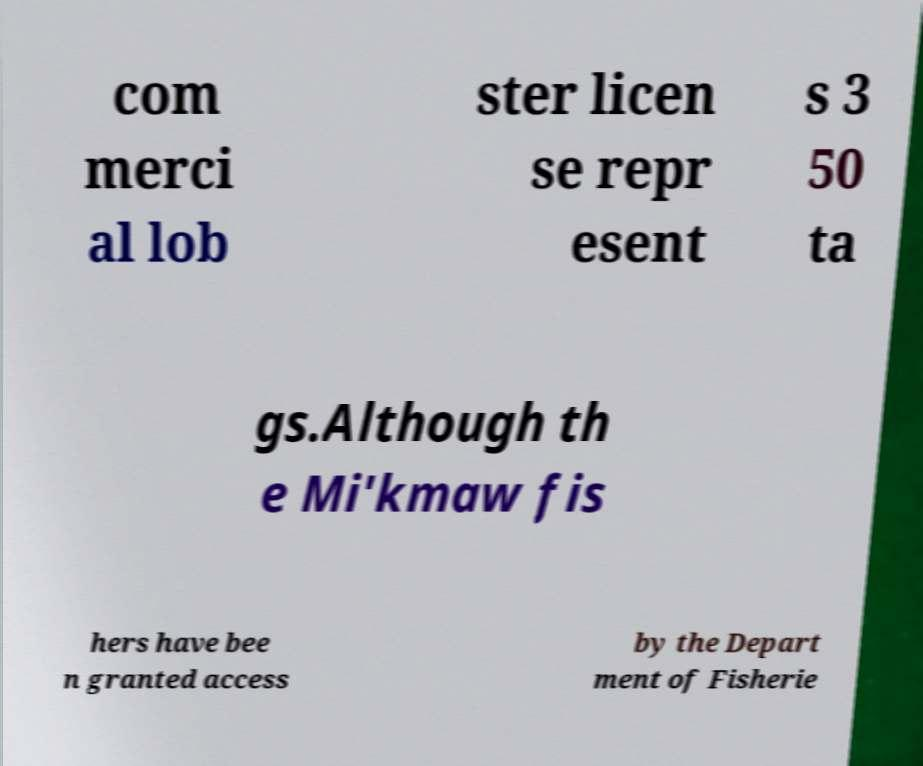Please identify and transcribe the text found in this image. com merci al lob ster licen se repr esent s 3 50 ta gs.Although th e Mi'kmaw fis hers have bee n granted access by the Depart ment of Fisherie 